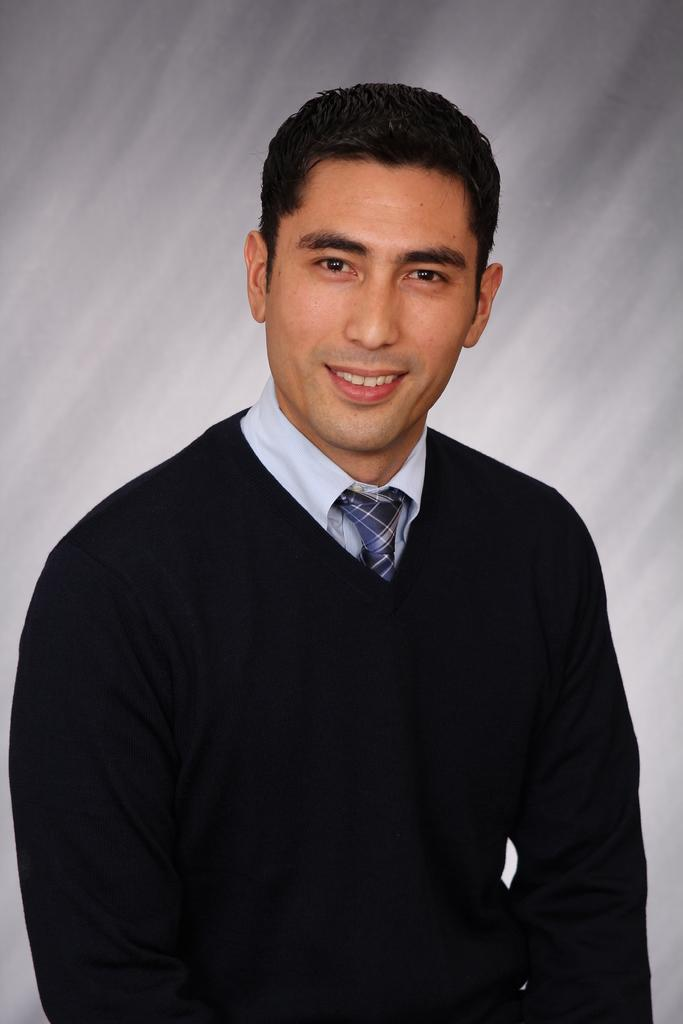Who is the main subject in the foreground of the image? There is a man in the foreground of the image. What is the man wearing? The man is wearing a black dress and a blue tie. How does the man appear in the image? The man has a smile on his face. What is the color of the background in the image? The background of the image is white. What type of mitten is the man holding in the image? There is no mitten present in the image. What idea does the man have in the image? The image does not convey any specific ideas or thoughts of the man. 